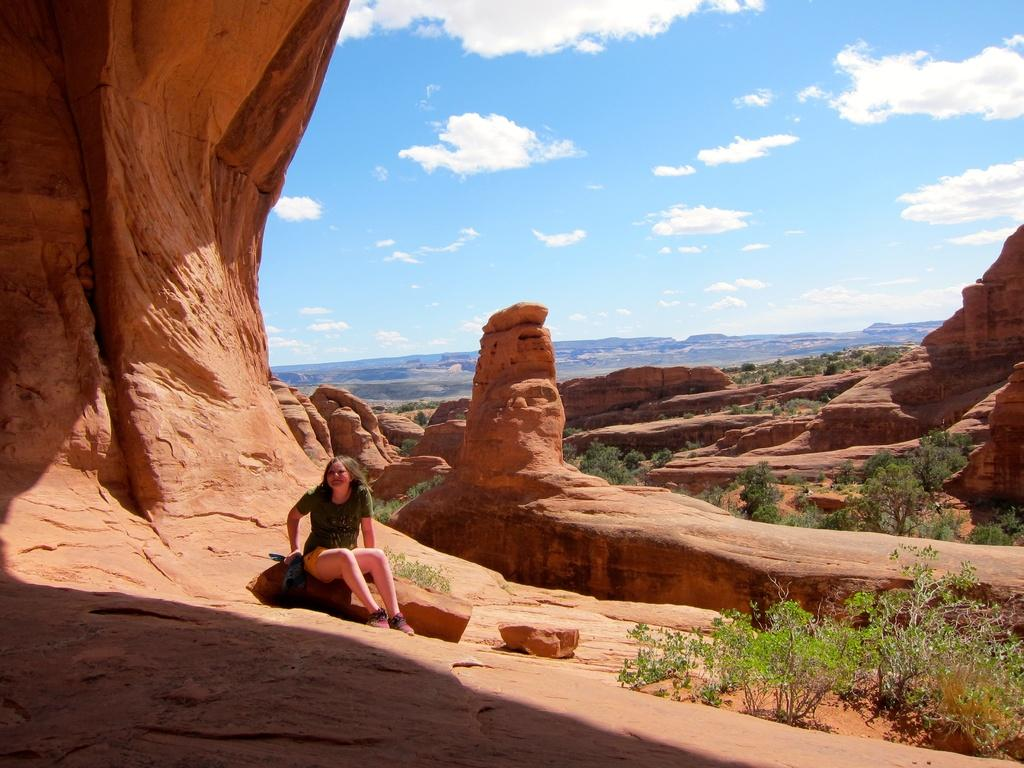What is the girl in the image doing? The girl is sitting on a rock in the image. What type of natural features can be seen in the image? There are trees, rocks, and mountains visible in the image. What is visible in the background of the image? The sky is visible in the background of the image, with clouds present. What type of land is the cannon placed on in the image? There is no cannon present in the image. What class is the girl attending in the image? There is no indication of a class or educational setting in the image. 